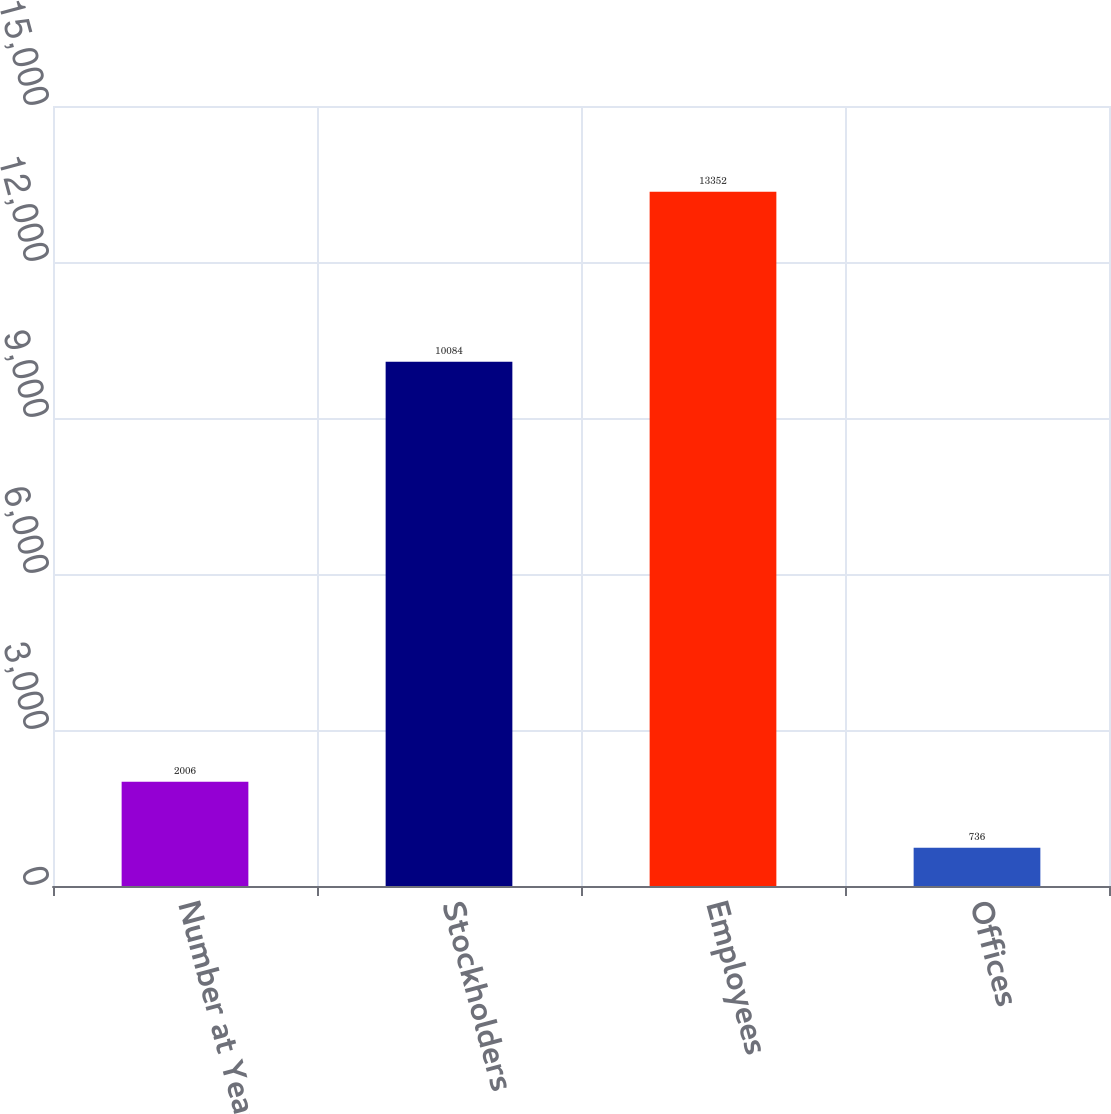Convert chart to OTSL. <chart><loc_0><loc_0><loc_500><loc_500><bar_chart><fcel>Number at Year-End<fcel>Stockholders<fcel>Employees<fcel>Offices<nl><fcel>2006<fcel>10084<fcel>13352<fcel>736<nl></chart> 